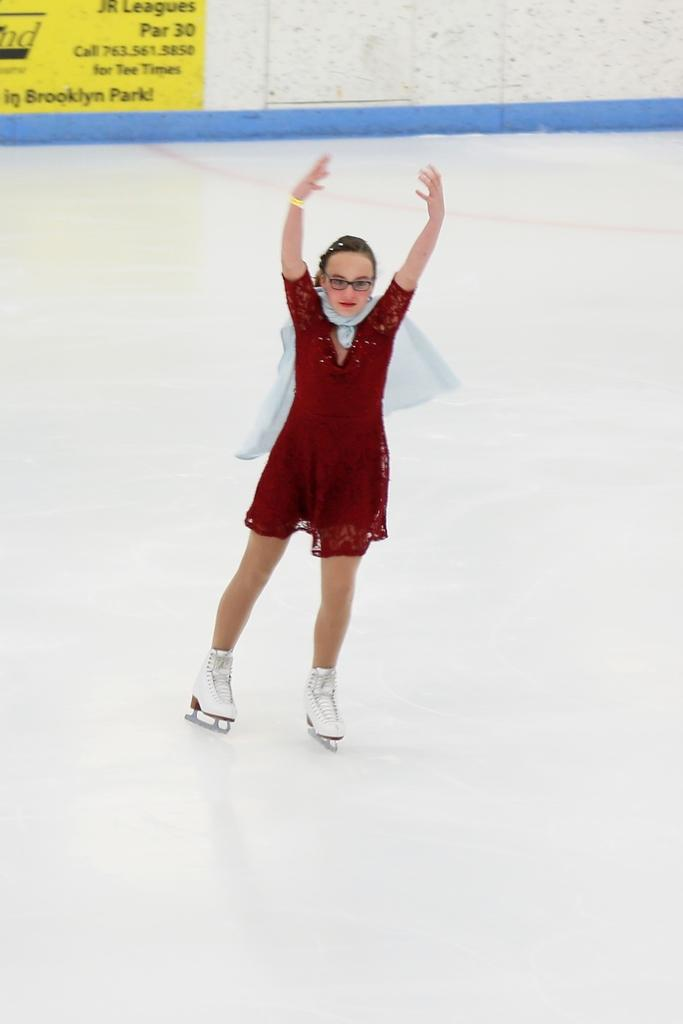Who is the main subject in the image? There is a woman in the image. What is the woman doing in the image? The woman is ice skating. What can be seen in the background of the image? There is a banner on the wall in the background of the image. What book is the woman reading while ice skating in the image? There is no book present in the image, and the woman is ice skating, not reading. 